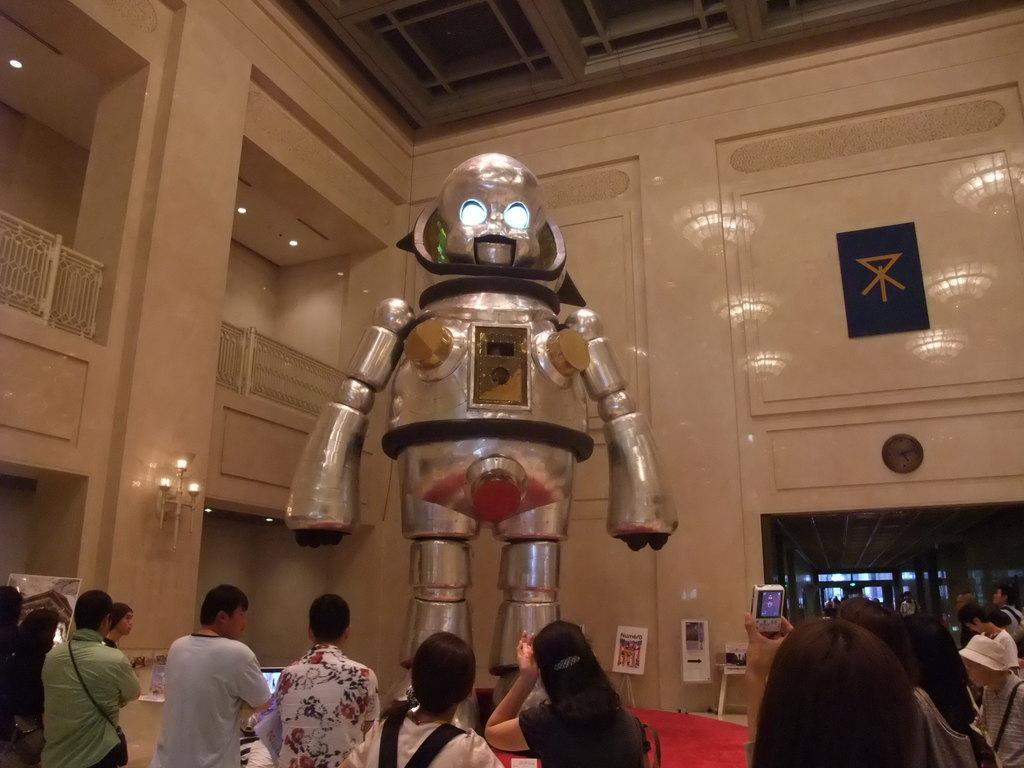Describe this image in one or two sentences. This is an inside view of a room. Here I can see a robot. At the bottom of the image I can see few people are standing and a person is holding a mobile in the hand and capturing the picture of this robot. In the background, I can see the wall. On the right side, I can see a black color board which is attached to this wall. 